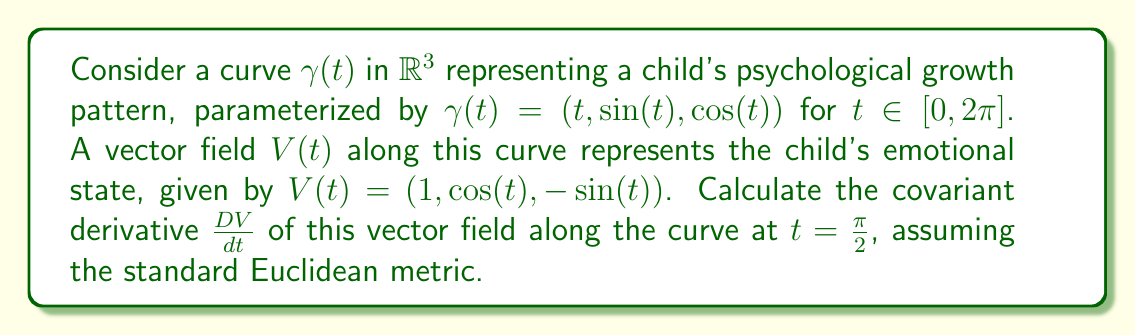Help me with this question. To calculate the covariant derivative of the vector field $V(t)$ along the curve $\gamma(t)$, we follow these steps:

1) The covariant derivative in Euclidean space is given by:

   $$\frac{DV}{dt} = \frac{dV}{dt} - \langle \frac{dV}{dt}, T \rangle T$$

   where $T$ is the unit tangent vector to the curve.

2) First, we calculate $\frac{d\gamma}{dt}$:
   
   $$\frac{d\gamma}{dt} = (1, \cos(t), -\sin(t))$$

3) The unit tangent vector $T$ is:

   $$T = \frac{\frac{d\gamma}{dt}}{|\frac{d\gamma}{dt}|} = \frac{(1, \cos(t), -\sin(t))}{\sqrt{1 + \cos^2(t) + \sin^2(t)}} = \frac{(1, \cos(t), -\sin(t))}{\sqrt{2}}$$

4) Now, we calculate $\frac{dV}{dt}$:

   $$\frac{dV}{dt} = (0, -\sin(t), -\cos(t))$$

5) At $t = \frac{\pi}{2}$:

   $$\frac{dV}{dt}|_{t=\frac{\pi}{2}} = (0, -1, 0)$$
   $$T|_{t=\frac{\pi}{2}} = \frac{(1, 0, -1)}{\sqrt{2}}$$

6) Now we can calculate $\langle \frac{dV}{dt}, T \rangle$ at $t = \frac{\pi}{2}$:

   $$\langle \frac{dV}{dt}, T \rangle|_{t=\frac{\pi}{2}} = \langle (0, -1, 0), \frac{(1, 0, -1)}{\sqrt{2}} \rangle = 0$$

7) Therefore, the covariant derivative at $t = \frac{\pi}{2}$ is:

   $$\frac{DV}{dt}|_{t=\frac{\pi}{2}} = \frac{dV}{dt}|_{t=\frac{\pi}{2}} - 0 = (0, -1, 0)$$

This result indicates that at $t = \frac{\pi}{2}$, the vector field is changing only in the y-direction, which could represent a significant shift in a specific aspect of the child's emotional state.
Answer: $(0, -1, 0)$ 